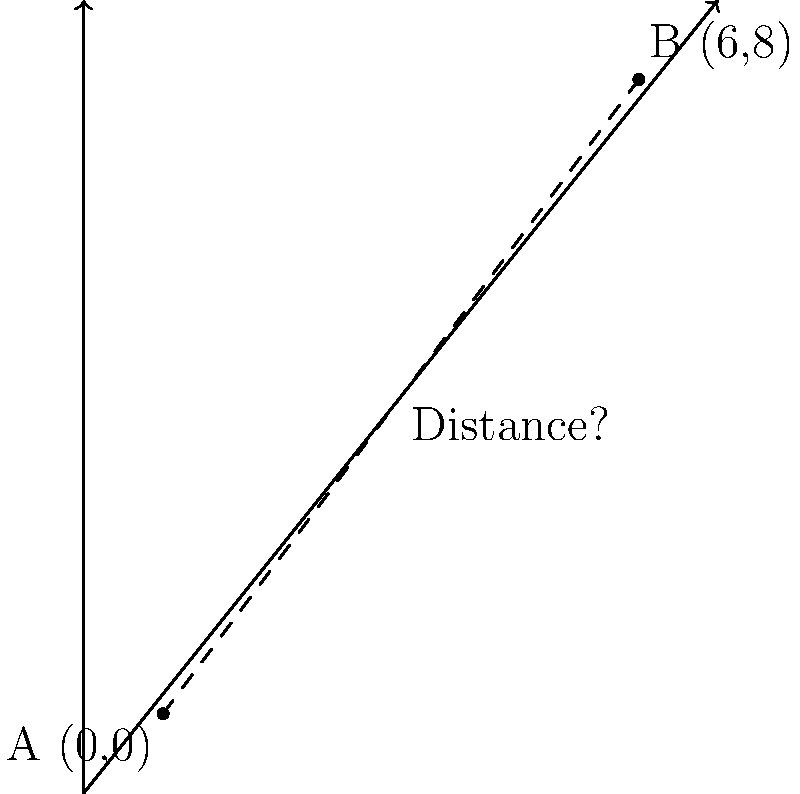In your grandmother's story, she mentions two significant locations: her childhood home (point A) and her favorite picnic spot (point B). Using the coordinate system on the map, her home is located at (0,0) and the picnic spot at (6,8). Calculate the straight-line distance between these two locations using the distance formula. To find the distance between two points, we use the distance formula:

$$d = \sqrt{(x_2 - x_1)^2 + (y_2 - y_1)^2}$$

Where $(x_1, y_1)$ are the coordinates of point A and $(x_2, y_2)$ are the coordinates of point B.

Given:
Point A (childhood home): $(0, 0)$
Point B (picnic spot): $(6, 8)$

Step 1: Substitute the values into the formula:
$$d = \sqrt{(6 - 0)^2 + (8 - 0)^2}$$

Step 2: Simplify inside the parentheses:
$$d = \sqrt{6^2 + 8^2}$$

Step 3: Calculate the squares:
$$d = \sqrt{36 + 64}$$

Step 4: Add inside the square root:
$$d = \sqrt{100}$$

Step 5: Simplify the square root:
$$d = 10$$

Therefore, the straight-line distance between your grandmother's childhood home and her favorite picnic spot is 10 units.
Answer: 10 units 